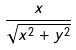<formula> <loc_0><loc_0><loc_500><loc_500>\frac { x } { \sqrt { x ^ { 2 } + y ^ { 2 } } }</formula> 